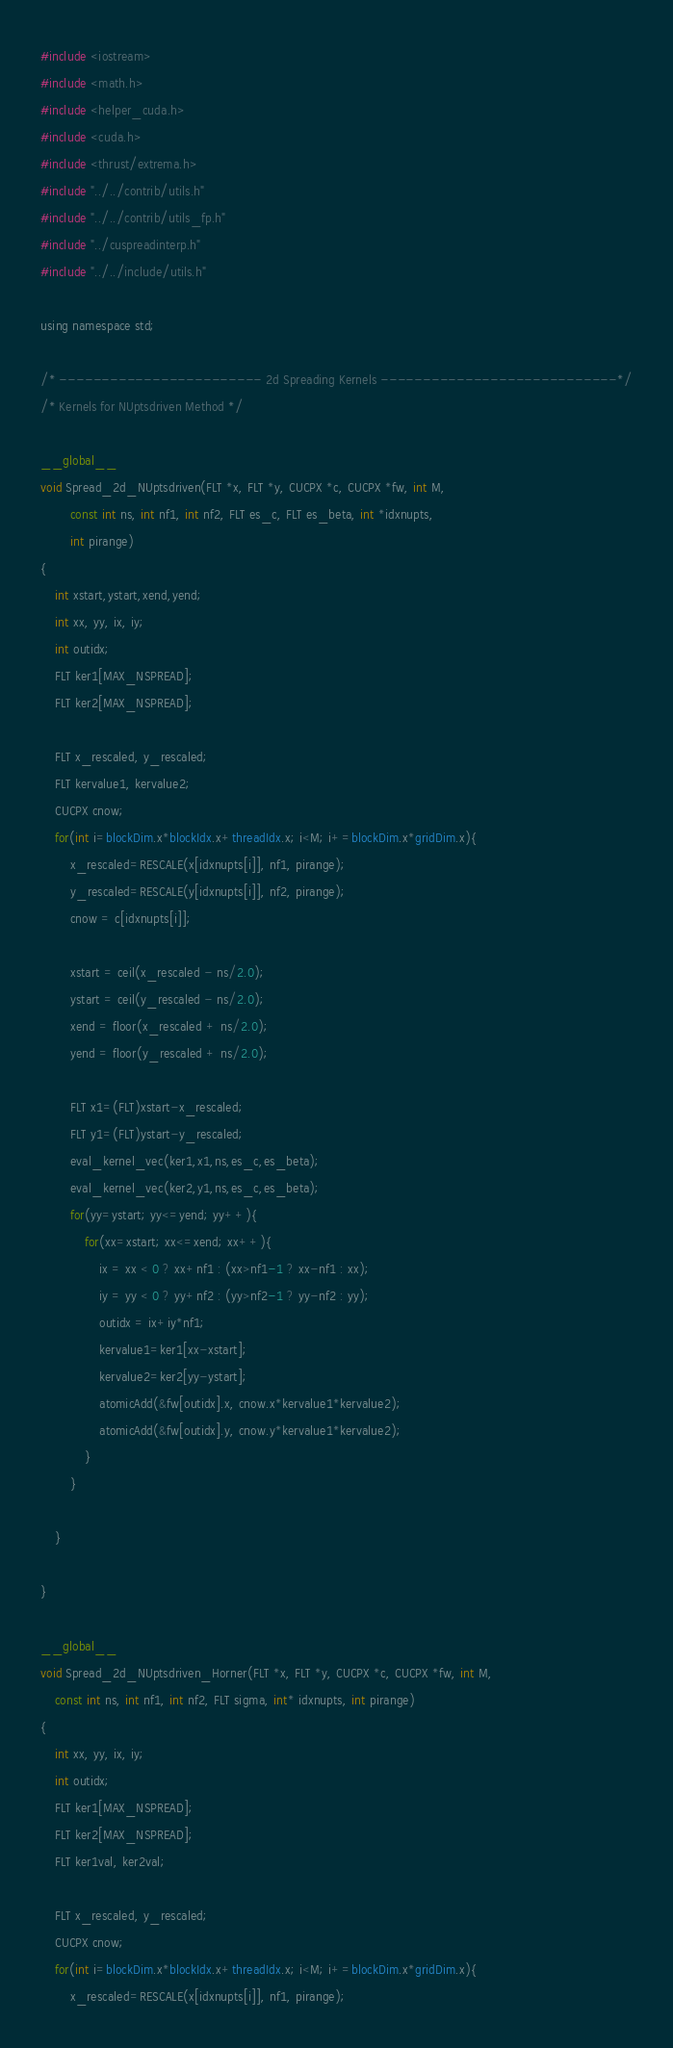Convert code to text. <code><loc_0><loc_0><loc_500><loc_500><_Cuda_>#include <iostream>
#include <math.h>
#include <helper_cuda.h>
#include <cuda.h>
#include <thrust/extrema.h>
#include "../../contrib/utils.h"
#include "../../contrib/utils_fp.h"
#include "../cuspreadinterp.h"
#include "../../include/utils.h"

using namespace std;

/* ------------------------ 2d Spreading Kernels ----------------------------*/
/* Kernels for NUptsdriven Method */

__global__
void Spread_2d_NUptsdriven(FLT *x, FLT *y, CUCPX *c, CUCPX *fw, int M, 
		const int ns, int nf1, int nf2, FLT es_c, FLT es_beta, int *idxnupts, 
		int pirange)
{
	int xstart,ystart,xend,yend;
	int xx, yy, ix, iy;
	int outidx;
	FLT ker1[MAX_NSPREAD];
	FLT ker2[MAX_NSPREAD];

	FLT x_rescaled, y_rescaled;
	FLT kervalue1, kervalue2;
	CUCPX cnow;
	for(int i=blockDim.x*blockIdx.x+threadIdx.x; i<M; i+=blockDim.x*gridDim.x){
		x_rescaled=RESCALE(x[idxnupts[i]], nf1, pirange);
		y_rescaled=RESCALE(y[idxnupts[i]], nf2, pirange);
		cnow = c[idxnupts[i]];

		xstart = ceil(x_rescaled - ns/2.0);
		ystart = ceil(y_rescaled - ns/2.0);
		xend = floor(x_rescaled + ns/2.0);
		yend = floor(y_rescaled + ns/2.0);

		FLT x1=(FLT)xstart-x_rescaled;
		FLT y1=(FLT)ystart-y_rescaled;
		eval_kernel_vec(ker1,x1,ns,es_c,es_beta);
		eval_kernel_vec(ker2,y1,ns,es_c,es_beta);
		for(yy=ystart; yy<=yend; yy++){
			for(xx=xstart; xx<=xend; xx++){
				ix = xx < 0 ? xx+nf1 : (xx>nf1-1 ? xx-nf1 : xx);
				iy = yy < 0 ? yy+nf2 : (yy>nf2-1 ? yy-nf2 : yy);
				outidx = ix+iy*nf1;
				kervalue1=ker1[xx-xstart];
				kervalue2=ker2[yy-ystart];
				atomicAdd(&fw[outidx].x, cnow.x*kervalue1*kervalue2);
				atomicAdd(&fw[outidx].y, cnow.y*kervalue1*kervalue2);
			}
		}

	}

}

__global__
void Spread_2d_NUptsdriven_Horner(FLT *x, FLT *y, CUCPX *c, CUCPX *fw, int M, 
	const int ns, int nf1, int nf2, FLT sigma, int* idxnupts, int pirange)
{
	int xx, yy, ix, iy;
	int outidx;
	FLT ker1[MAX_NSPREAD];
	FLT ker2[MAX_NSPREAD];
	FLT ker1val, ker2val;

	FLT x_rescaled, y_rescaled;
	CUCPX cnow;
	for(int i=blockDim.x*blockIdx.x+threadIdx.x; i<M; i+=blockDim.x*gridDim.x){
		x_rescaled=RESCALE(x[idxnupts[i]], nf1, pirange);</code> 